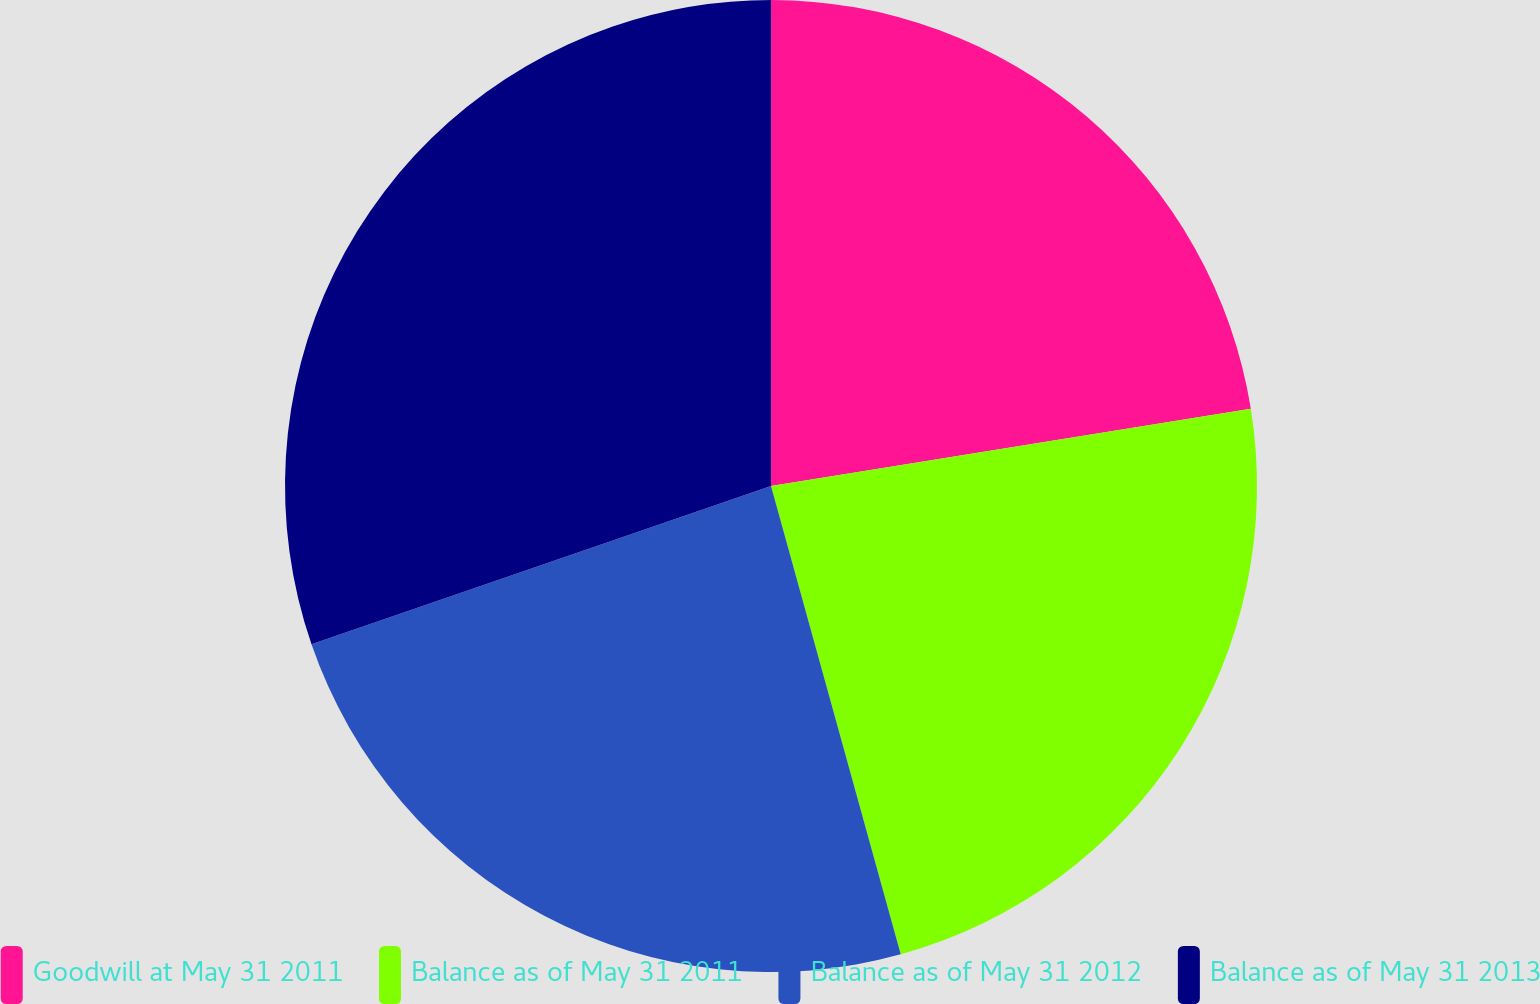Convert chart to OTSL. <chart><loc_0><loc_0><loc_500><loc_500><pie_chart><fcel>Goodwill at May 31 2011<fcel>Balance as of May 31 2011<fcel>Balance as of May 31 2012<fcel>Balance as of May 31 2013<nl><fcel>22.46%<fcel>23.24%<fcel>24.02%<fcel>30.28%<nl></chart> 